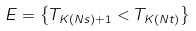Convert formula to latex. <formula><loc_0><loc_0><loc_500><loc_500>E = \left \{ T _ { K ( N s ) + 1 } < T _ { K ( N t ) } \right \}</formula> 